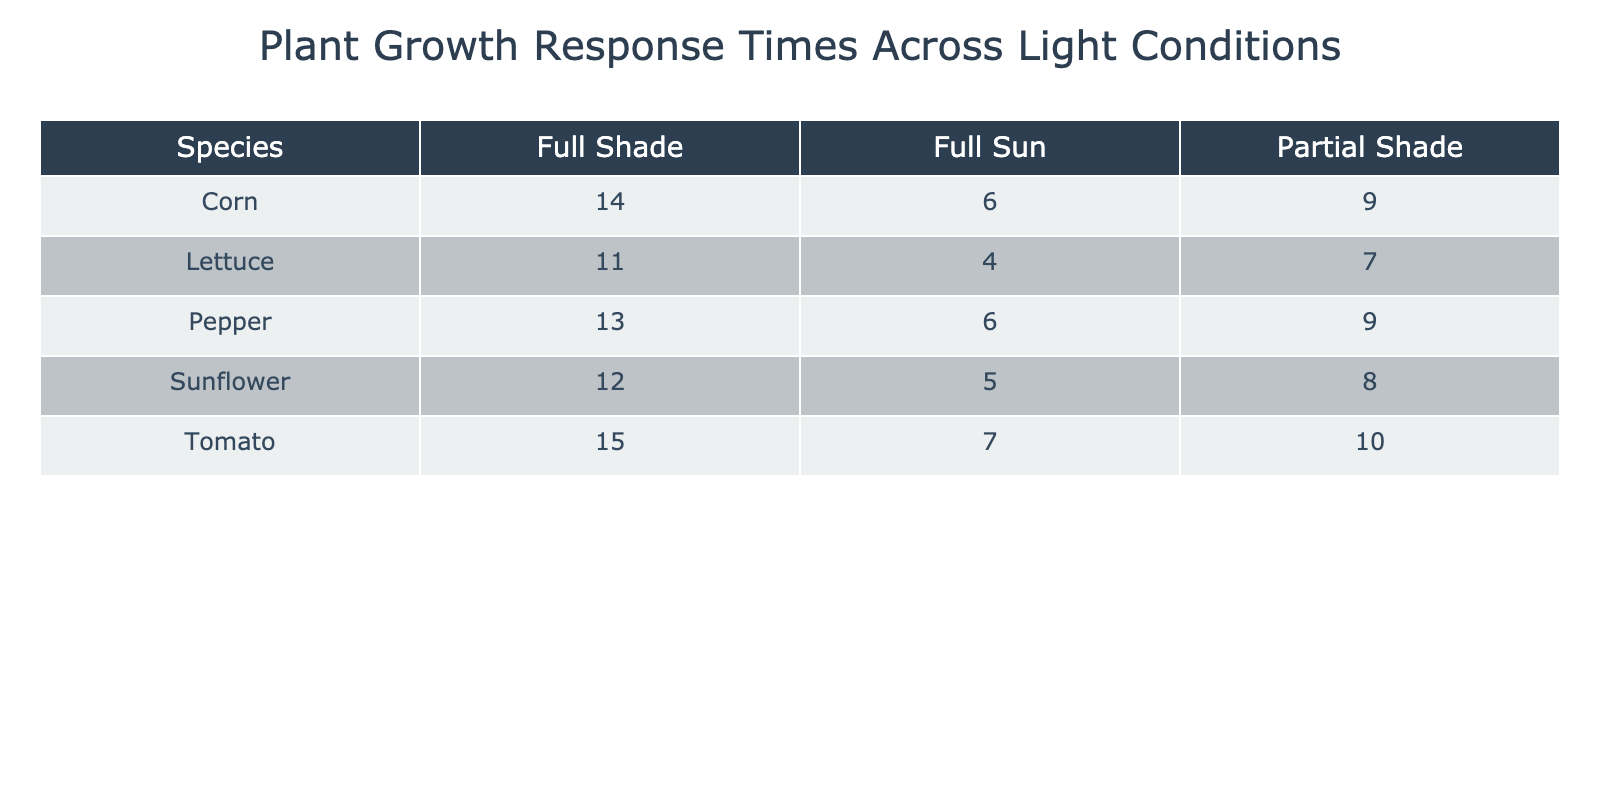What is the average growth response time for Lettuce under Full Sun? The table shows that the average growth response time for Lettuce under Full Sun is 4 days. This value can be directly found in the corresponding cell for Lettuce and Full Sun.
Answer: 4 days Which species has the longest growth response time in Full Shade? By examining the Full Shade column across all species, the longest growth response time is 15 days for Tomato. This is the highest value listed in that column.
Answer: Tomato What is the difference in average growth response time between Sunflower in Full Sun and in Full Shade? From the table, Sunflower shows an average growth response time of 5 days in Full Sun and 12 days in Full Shade. The difference is calculated as 12 - 5 = 7 days.
Answer: 7 days Is the average growth response time for Corn in Partial Shade shorter than that for Pepper in Full Shade? Looking at the table, Corn in Partial Shade has an average growth response time of 9 days, while Pepper in Full Shade has 13 days. Since 9 is less than 13, the statement is true.
Answer: Yes What is the total average growth response time for Tomato across all light conditions? The average growth response times for Tomato in different light conditions are 7 days (Full Sun), 10 days (Partial Shade), and 15 days (Full Shade). Adding these gives 7 + 10 + 15 = 32 days. There are 3 light conditions, so the average is 32 / 3 = approximately 10.67 days.
Answer: 10.67 days Under which light condition does Lettuce grow the fastest? The table illustrates that Lettuce grows the fastest in Full Sun with an average response time of 4 days, which is less than its times in Partial Shade (7 days) and Full Shade (11 days). Thus, Full Sun is the condition with the shortest time.
Answer: Full Sun How many species have an average growth response time of more than 10 days in Full Shade? Analyzing the Full Shade column, we find that both Tomato (15 days) and Pepper (13 days) have growth response times greater than 10 days, resulting in a total of 2 species meeting the criteria.
Answer: 2 species What is the average growth response time across all species in Partial Shade? The average growth response times in Partial Shade are: Sunflower (8 days), Tomato (10 days), Corn (9 days), and Pepper (9 days). Adding these values yields 8 + 10 + 9 + 9 = 36 days. With 4 species, the average is 36 / 4 = 9 days.
Answer: 9 days 